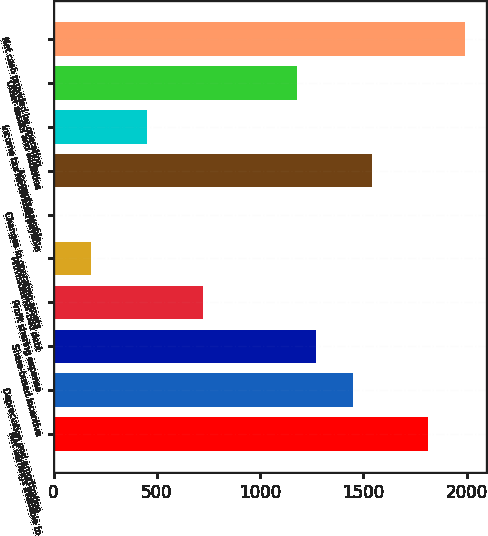Convert chart. <chart><loc_0><loc_0><loc_500><loc_500><bar_chart><fcel>Net earnings available to<fcel>Depreciation and amortization<fcel>Share-based incentive<fcel>Profit sharing expense<fcel>Provisions for bad debt<fcel>Changes in operating assets<fcel>Accounts payable<fcel>Income tax receivable/payable<fcel>Other assets and liabilities<fcel>Net cash provided by operating<nl><fcel>1811.2<fcel>1449.48<fcel>1268.62<fcel>726.04<fcel>183.46<fcel>2.6<fcel>1539.91<fcel>454.75<fcel>1178.19<fcel>1992.06<nl></chart> 